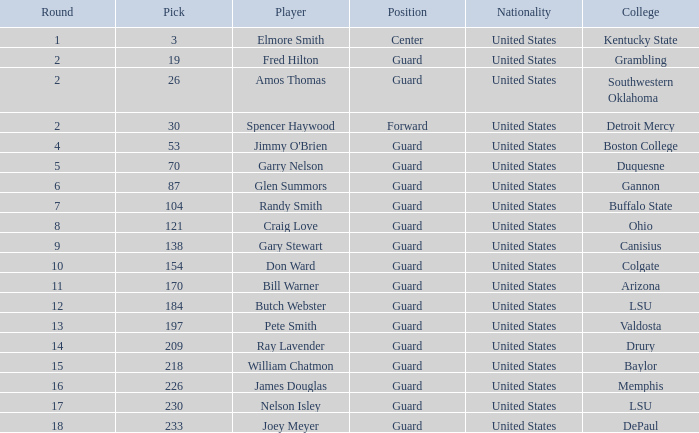What is the complete pick for boston college? 1.0. 